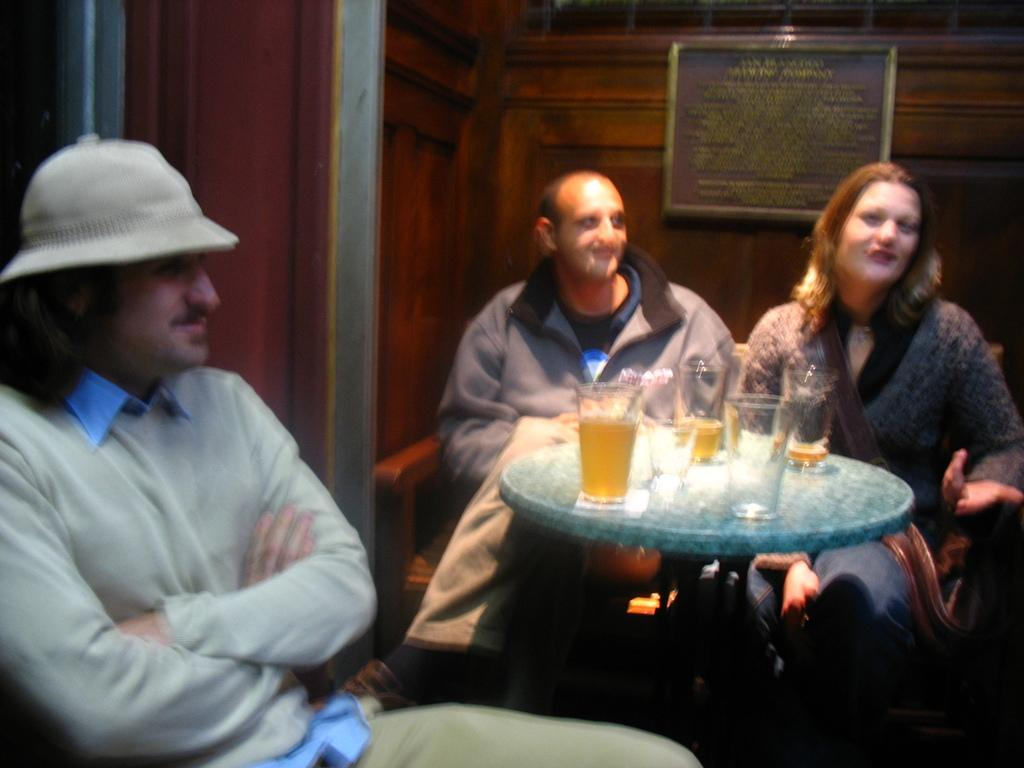How many people are in total are in the image? There are two men and a woman in the image, making a total of three people. What are the individuals in the image doing? The individuals are sitting in the image. What is in front of the people? There is a table in front of them. What can be seen on the table? There are glasses on the table. What is visible in the background of the image? There is a wall in the background of the image. What is on the wall? There is a photo frame on the wall. What type of sign can be seen in the image? There is no sign present in the image. What kind of tree is visible in the image? There is no tree visible in the image. 